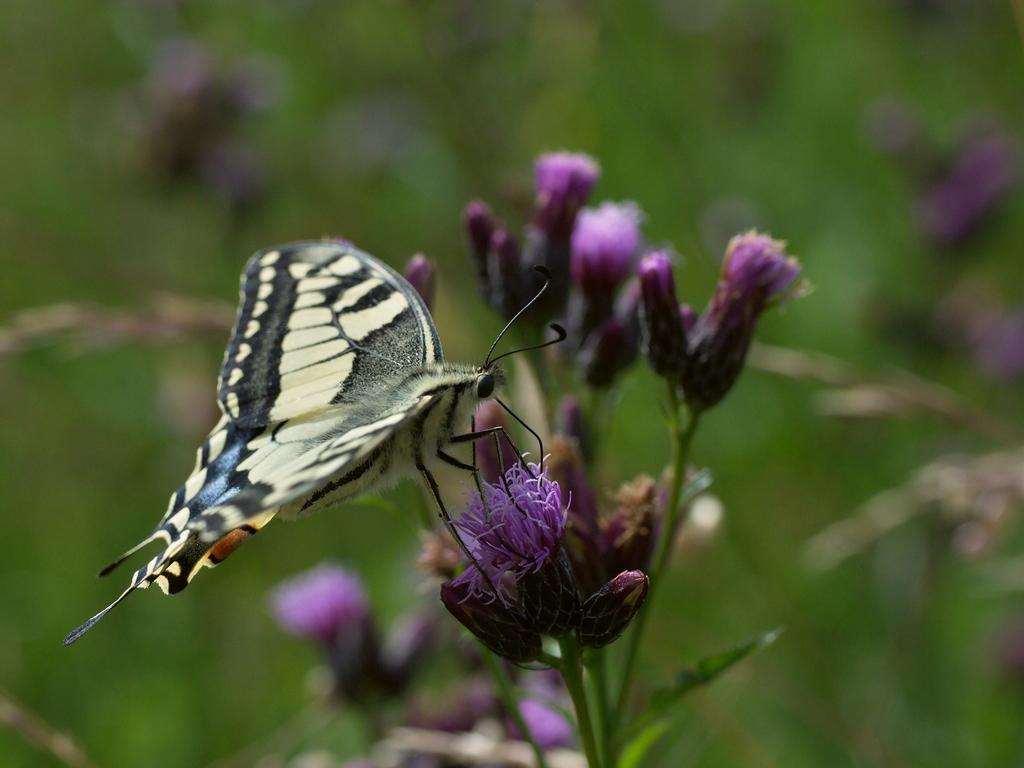Please provide a concise description of this image. In this image I can see a butterfly. This is a macro photography of a butterfly sitting on a flower with a blurred background. 